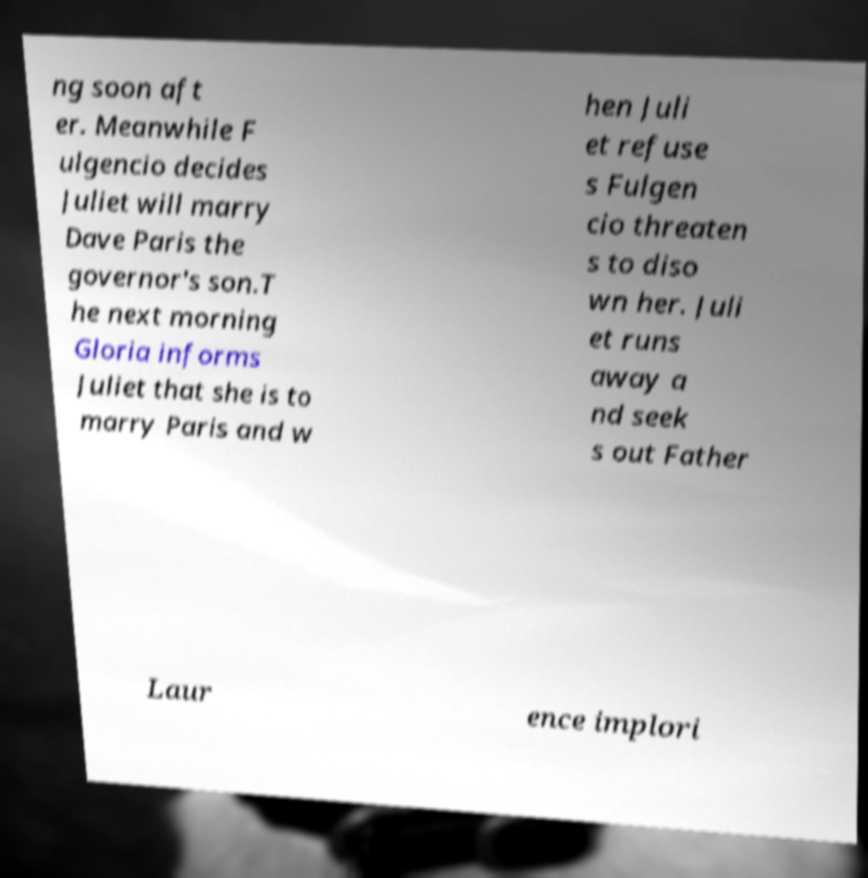Please read and relay the text visible in this image. What does it say? ng soon aft er. Meanwhile F ulgencio decides Juliet will marry Dave Paris the governor's son.T he next morning Gloria informs Juliet that she is to marry Paris and w hen Juli et refuse s Fulgen cio threaten s to diso wn her. Juli et runs away a nd seek s out Father Laur ence implori 